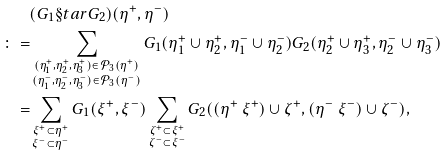Convert formula to latex. <formula><loc_0><loc_0><loc_500><loc_500>& ( G _ { 1 } \S t a r G _ { 2 } ) ( \eta ^ { + } , \eta ^ { - } ) \\ \colon = & \sum _ { \substack { ( \eta ^ { + } _ { 1 } , \eta ^ { + } _ { 2 } , \eta ^ { + } _ { 3 } ) \in \mathcal { P } _ { 3 } ( \eta ^ { + } ) \\ ( \eta ^ { - } _ { 1 } , \eta ^ { - } _ { 2 } , \eta ^ { - } _ { 3 } ) \in \mathcal { P } _ { 3 } ( \eta ^ { - } ) } } G _ { 1 } ( \eta ^ { + } _ { 1 } \cup \eta ^ { + } _ { 2 } , \eta ^ { - } _ { 1 } \cup \eta ^ { - } _ { 2 } ) G _ { 2 } ( \eta ^ { + } _ { 2 } \cup \eta ^ { + } _ { 3 } , \eta ^ { - } _ { 2 } \cup \eta ^ { - } _ { 3 } ) \\ = & \sum _ { \substack { \xi ^ { + } \subset \eta ^ { + } \\ \xi ^ { - } \subset \eta ^ { - } } } G _ { 1 } ( \xi ^ { + } , \xi ^ { - } ) \sum _ { \substack { \zeta ^ { + } \subset \xi ^ { + } \\ \zeta ^ { - } \subset \xi ^ { - } } } G _ { 2 } ( ( \eta ^ { + } \ \xi ^ { + } ) \cup \zeta ^ { + } , ( \eta ^ { - } \ \xi ^ { - } ) \cup \zeta ^ { - } ) ,</formula> 